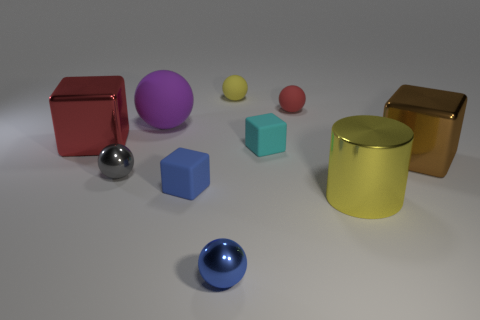Subtract all yellow balls. How many balls are left? 4 Subtract all small yellow balls. How many balls are left? 4 Subtract all green spheres. Subtract all blue cubes. How many spheres are left? 5 Subtract all blocks. How many objects are left? 6 Subtract all small cyan matte objects. Subtract all large purple rubber spheres. How many objects are left? 8 Add 5 big metallic cubes. How many big metallic cubes are left? 7 Add 4 cyan matte cylinders. How many cyan matte cylinders exist? 4 Subtract 1 blue blocks. How many objects are left? 9 